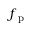<formula> <loc_0><loc_0><loc_500><loc_500>f _ { p }</formula> 